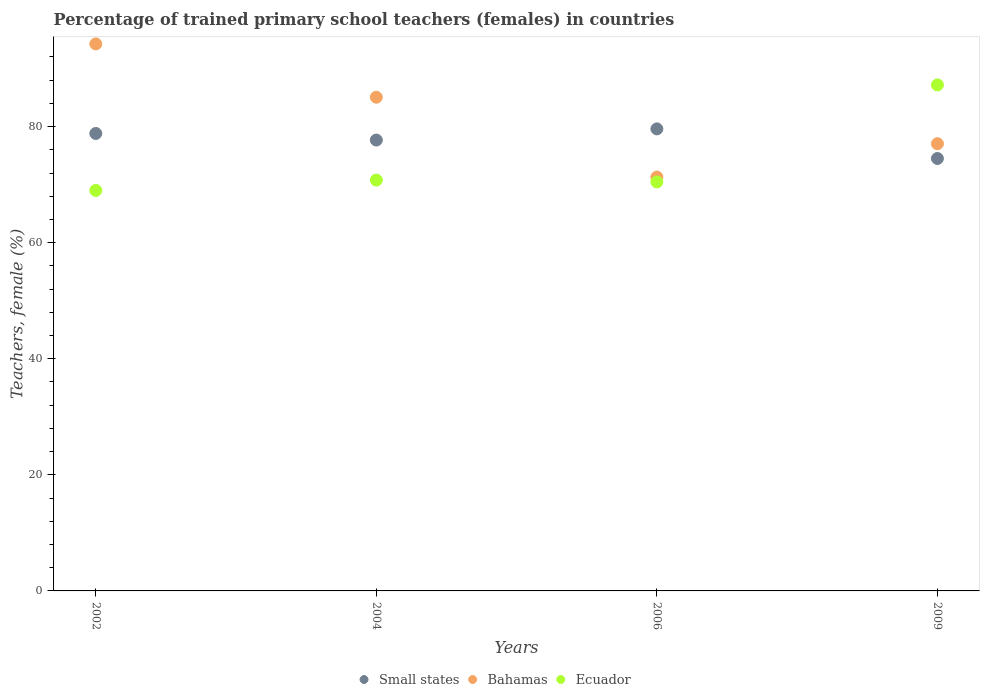What is the percentage of trained primary school teachers (females) in Small states in 2006?
Your answer should be compact. 79.6. Across all years, what is the maximum percentage of trained primary school teachers (females) in Small states?
Your answer should be very brief. 79.6. Across all years, what is the minimum percentage of trained primary school teachers (females) in Small states?
Provide a short and direct response. 74.5. What is the total percentage of trained primary school teachers (females) in Bahamas in the graph?
Your response must be concise. 327.65. What is the difference between the percentage of trained primary school teachers (females) in Ecuador in 2002 and that in 2004?
Your response must be concise. -1.78. What is the difference between the percentage of trained primary school teachers (females) in Small states in 2006 and the percentage of trained primary school teachers (females) in Bahamas in 2004?
Keep it short and to the point. -5.45. What is the average percentage of trained primary school teachers (females) in Small states per year?
Your answer should be compact. 77.65. In the year 2002, what is the difference between the percentage of trained primary school teachers (females) in Ecuador and percentage of trained primary school teachers (females) in Bahamas?
Your answer should be very brief. -25.24. In how many years, is the percentage of trained primary school teachers (females) in Bahamas greater than 4 %?
Keep it short and to the point. 4. What is the ratio of the percentage of trained primary school teachers (females) in Small states in 2002 to that in 2009?
Your answer should be compact. 1.06. Is the percentage of trained primary school teachers (females) in Bahamas in 2002 less than that in 2009?
Offer a very short reply. No. Is the difference between the percentage of trained primary school teachers (females) in Ecuador in 2004 and 2009 greater than the difference between the percentage of trained primary school teachers (females) in Bahamas in 2004 and 2009?
Provide a short and direct response. No. What is the difference between the highest and the second highest percentage of trained primary school teachers (females) in Small states?
Give a very brief answer. 0.79. What is the difference between the highest and the lowest percentage of trained primary school teachers (females) in Small states?
Provide a short and direct response. 5.1. Is the percentage of trained primary school teachers (females) in Bahamas strictly greater than the percentage of trained primary school teachers (females) in Small states over the years?
Offer a terse response. No. How many years are there in the graph?
Provide a short and direct response. 4. Does the graph contain grids?
Provide a short and direct response. No. How many legend labels are there?
Provide a succinct answer. 3. How are the legend labels stacked?
Keep it short and to the point. Horizontal. What is the title of the graph?
Offer a terse response. Percentage of trained primary school teachers (females) in countries. What is the label or title of the X-axis?
Ensure brevity in your answer.  Years. What is the label or title of the Y-axis?
Your answer should be compact. Teachers, female (%). What is the Teachers, female (%) in Small states in 2002?
Ensure brevity in your answer.  78.81. What is the Teachers, female (%) of Bahamas in 2002?
Give a very brief answer. 94.24. What is the Teachers, female (%) of Ecuador in 2002?
Your answer should be compact. 69. What is the Teachers, female (%) of Small states in 2004?
Provide a short and direct response. 77.68. What is the Teachers, female (%) of Bahamas in 2004?
Keep it short and to the point. 85.06. What is the Teachers, female (%) of Ecuador in 2004?
Give a very brief answer. 70.78. What is the Teachers, female (%) of Small states in 2006?
Keep it short and to the point. 79.6. What is the Teachers, female (%) of Bahamas in 2006?
Keep it short and to the point. 71.3. What is the Teachers, female (%) in Ecuador in 2006?
Offer a terse response. 70.46. What is the Teachers, female (%) in Small states in 2009?
Offer a terse response. 74.5. What is the Teachers, female (%) of Bahamas in 2009?
Keep it short and to the point. 77.05. What is the Teachers, female (%) of Ecuador in 2009?
Keep it short and to the point. 87.18. Across all years, what is the maximum Teachers, female (%) of Small states?
Offer a very short reply. 79.6. Across all years, what is the maximum Teachers, female (%) of Bahamas?
Offer a terse response. 94.24. Across all years, what is the maximum Teachers, female (%) of Ecuador?
Your answer should be compact. 87.18. Across all years, what is the minimum Teachers, female (%) in Small states?
Your answer should be compact. 74.5. Across all years, what is the minimum Teachers, female (%) in Bahamas?
Offer a very short reply. 71.3. Across all years, what is the minimum Teachers, female (%) in Ecuador?
Ensure brevity in your answer.  69. What is the total Teachers, female (%) of Small states in the graph?
Ensure brevity in your answer.  310.59. What is the total Teachers, female (%) in Bahamas in the graph?
Provide a succinct answer. 327.65. What is the total Teachers, female (%) in Ecuador in the graph?
Give a very brief answer. 297.43. What is the difference between the Teachers, female (%) in Small states in 2002 and that in 2004?
Your answer should be compact. 1.14. What is the difference between the Teachers, female (%) in Bahamas in 2002 and that in 2004?
Offer a very short reply. 9.19. What is the difference between the Teachers, female (%) in Ecuador in 2002 and that in 2004?
Provide a short and direct response. -1.78. What is the difference between the Teachers, female (%) in Small states in 2002 and that in 2006?
Offer a very short reply. -0.79. What is the difference between the Teachers, female (%) in Bahamas in 2002 and that in 2006?
Your answer should be compact. 22.94. What is the difference between the Teachers, female (%) of Ecuador in 2002 and that in 2006?
Your answer should be compact. -1.46. What is the difference between the Teachers, female (%) in Small states in 2002 and that in 2009?
Offer a very short reply. 4.31. What is the difference between the Teachers, female (%) of Bahamas in 2002 and that in 2009?
Give a very brief answer. 17.2. What is the difference between the Teachers, female (%) in Ecuador in 2002 and that in 2009?
Provide a succinct answer. -18.18. What is the difference between the Teachers, female (%) in Small states in 2004 and that in 2006?
Offer a terse response. -1.93. What is the difference between the Teachers, female (%) in Bahamas in 2004 and that in 2006?
Offer a very short reply. 13.76. What is the difference between the Teachers, female (%) in Ecuador in 2004 and that in 2006?
Give a very brief answer. 0.32. What is the difference between the Teachers, female (%) in Small states in 2004 and that in 2009?
Provide a succinct answer. 3.18. What is the difference between the Teachers, female (%) of Bahamas in 2004 and that in 2009?
Offer a very short reply. 8.01. What is the difference between the Teachers, female (%) of Ecuador in 2004 and that in 2009?
Ensure brevity in your answer.  -16.4. What is the difference between the Teachers, female (%) of Small states in 2006 and that in 2009?
Your answer should be very brief. 5.1. What is the difference between the Teachers, female (%) of Bahamas in 2006 and that in 2009?
Provide a short and direct response. -5.75. What is the difference between the Teachers, female (%) in Ecuador in 2006 and that in 2009?
Provide a short and direct response. -16.72. What is the difference between the Teachers, female (%) in Small states in 2002 and the Teachers, female (%) in Bahamas in 2004?
Your answer should be very brief. -6.24. What is the difference between the Teachers, female (%) in Small states in 2002 and the Teachers, female (%) in Ecuador in 2004?
Your answer should be very brief. 8.03. What is the difference between the Teachers, female (%) of Bahamas in 2002 and the Teachers, female (%) of Ecuador in 2004?
Ensure brevity in your answer.  23.46. What is the difference between the Teachers, female (%) in Small states in 2002 and the Teachers, female (%) in Bahamas in 2006?
Your answer should be very brief. 7.51. What is the difference between the Teachers, female (%) of Small states in 2002 and the Teachers, female (%) of Ecuador in 2006?
Provide a succinct answer. 8.35. What is the difference between the Teachers, female (%) of Bahamas in 2002 and the Teachers, female (%) of Ecuador in 2006?
Your response must be concise. 23.78. What is the difference between the Teachers, female (%) in Small states in 2002 and the Teachers, female (%) in Bahamas in 2009?
Keep it short and to the point. 1.76. What is the difference between the Teachers, female (%) in Small states in 2002 and the Teachers, female (%) in Ecuador in 2009?
Offer a terse response. -8.37. What is the difference between the Teachers, female (%) of Bahamas in 2002 and the Teachers, female (%) of Ecuador in 2009?
Give a very brief answer. 7.06. What is the difference between the Teachers, female (%) of Small states in 2004 and the Teachers, female (%) of Bahamas in 2006?
Provide a succinct answer. 6.38. What is the difference between the Teachers, female (%) of Small states in 2004 and the Teachers, female (%) of Ecuador in 2006?
Your answer should be compact. 7.21. What is the difference between the Teachers, female (%) in Bahamas in 2004 and the Teachers, female (%) in Ecuador in 2006?
Your answer should be compact. 14.59. What is the difference between the Teachers, female (%) of Small states in 2004 and the Teachers, female (%) of Bahamas in 2009?
Provide a short and direct response. 0.63. What is the difference between the Teachers, female (%) of Small states in 2004 and the Teachers, female (%) of Ecuador in 2009?
Give a very brief answer. -9.5. What is the difference between the Teachers, female (%) in Bahamas in 2004 and the Teachers, female (%) in Ecuador in 2009?
Make the answer very short. -2.12. What is the difference between the Teachers, female (%) in Small states in 2006 and the Teachers, female (%) in Bahamas in 2009?
Offer a very short reply. 2.55. What is the difference between the Teachers, female (%) in Small states in 2006 and the Teachers, female (%) in Ecuador in 2009?
Offer a terse response. -7.58. What is the difference between the Teachers, female (%) in Bahamas in 2006 and the Teachers, female (%) in Ecuador in 2009?
Provide a succinct answer. -15.88. What is the average Teachers, female (%) in Small states per year?
Give a very brief answer. 77.65. What is the average Teachers, female (%) of Bahamas per year?
Your response must be concise. 81.91. What is the average Teachers, female (%) of Ecuador per year?
Provide a succinct answer. 74.36. In the year 2002, what is the difference between the Teachers, female (%) of Small states and Teachers, female (%) of Bahamas?
Your answer should be compact. -15.43. In the year 2002, what is the difference between the Teachers, female (%) in Small states and Teachers, female (%) in Ecuador?
Make the answer very short. 9.81. In the year 2002, what is the difference between the Teachers, female (%) in Bahamas and Teachers, female (%) in Ecuador?
Your response must be concise. 25.24. In the year 2004, what is the difference between the Teachers, female (%) of Small states and Teachers, female (%) of Bahamas?
Provide a succinct answer. -7.38. In the year 2004, what is the difference between the Teachers, female (%) of Small states and Teachers, female (%) of Ecuador?
Offer a terse response. 6.89. In the year 2004, what is the difference between the Teachers, female (%) of Bahamas and Teachers, female (%) of Ecuador?
Provide a succinct answer. 14.27. In the year 2006, what is the difference between the Teachers, female (%) in Small states and Teachers, female (%) in Bahamas?
Your answer should be very brief. 8.3. In the year 2006, what is the difference between the Teachers, female (%) of Small states and Teachers, female (%) of Ecuador?
Provide a succinct answer. 9.14. In the year 2006, what is the difference between the Teachers, female (%) of Bahamas and Teachers, female (%) of Ecuador?
Make the answer very short. 0.84. In the year 2009, what is the difference between the Teachers, female (%) in Small states and Teachers, female (%) in Bahamas?
Keep it short and to the point. -2.55. In the year 2009, what is the difference between the Teachers, female (%) in Small states and Teachers, female (%) in Ecuador?
Ensure brevity in your answer.  -12.68. In the year 2009, what is the difference between the Teachers, female (%) of Bahamas and Teachers, female (%) of Ecuador?
Your answer should be very brief. -10.13. What is the ratio of the Teachers, female (%) of Small states in 2002 to that in 2004?
Keep it short and to the point. 1.01. What is the ratio of the Teachers, female (%) of Bahamas in 2002 to that in 2004?
Your answer should be very brief. 1.11. What is the ratio of the Teachers, female (%) of Ecuador in 2002 to that in 2004?
Offer a terse response. 0.97. What is the ratio of the Teachers, female (%) in Bahamas in 2002 to that in 2006?
Ensure brevity in your answer.  1.32. What is the ratio of the Teachers, female (%) of Ecuador in 2002 to that in 2006?
Your answer should be very brief. 0.98. What is the ratio of the Teachers, female (%) in Small states in 2002 to that in 2009?
Provide a succinct answer. 1.06. What is the ratio of the Teachers, female (%) in Bahamas in 2002 to that in 2009?
Ensure brevity in your answer.  1.22. What is the ratio of the Teachers, female (%) of Ecuador in 2002 to that in 2009?
Offer a very short reply. 0.79. What is the ratio of the Teachers, female (%) in Small states in 2004 to that in 2006?
Provide a short and direct response. 0.98. What is the ratio of the Teachers, female (%) of Bahamas in 2004 to that in 2006?
Make the answer very short. 1.19. What is the ratio of the Teachers, female (%) in Ecuador in 2004 to that in 2006?
Keep it short and to the point. 1. What is the ratio of the Teachers, female (%) of Small states in 2004 to that in 2009?
Your response must be concise. 1.04. What is the ratio of the Teachers, female (%) of Bahamas in 2004 to that in 2009?
Your answer should be very brief. 1.1. What is the ratio of the Teachers, female (%) of Ecuador in 2004 to that in 2009?
Offer a very short reply. 0.81. What is the ratio of the Teachers, female (%) in Small states in 2006 to that in 2009?
Offer a terse response. 1.07. What is the ratio of the Teachers, female (%) in Bahamas in 2006 to that in 2009?
Your response must be concise. 0.93. What is the ratio of the Teachers, female (%) of Ecuador in 2006 to that in 2009?
Provide a short and direct response. 0.81. What is the difference between the highest and the second highest Teachers, female (%) in Small states?
Your answer should be compact. 0.79. What is the difference between the highest and the second highest Teachers, female (%) of Bahamas?
Keep it short and to the point. 9.19. What is the difference between the highest and the second highest Teachers, female (%) of Ecuador?
Provide a short and direct response. 16.4. What is the difference between the highest and the lowest Teachers, female (%) of Small states?
Offer a very short reply. 5.1. What is the difference between the highest and the lowest Teachers, female (%) of Bahamas?
Offer a very short reply. 22.94. What is the difference between the highest and the lowest Teachers, female (%) of Ecuador?
Your response must be concise. 18.18. 